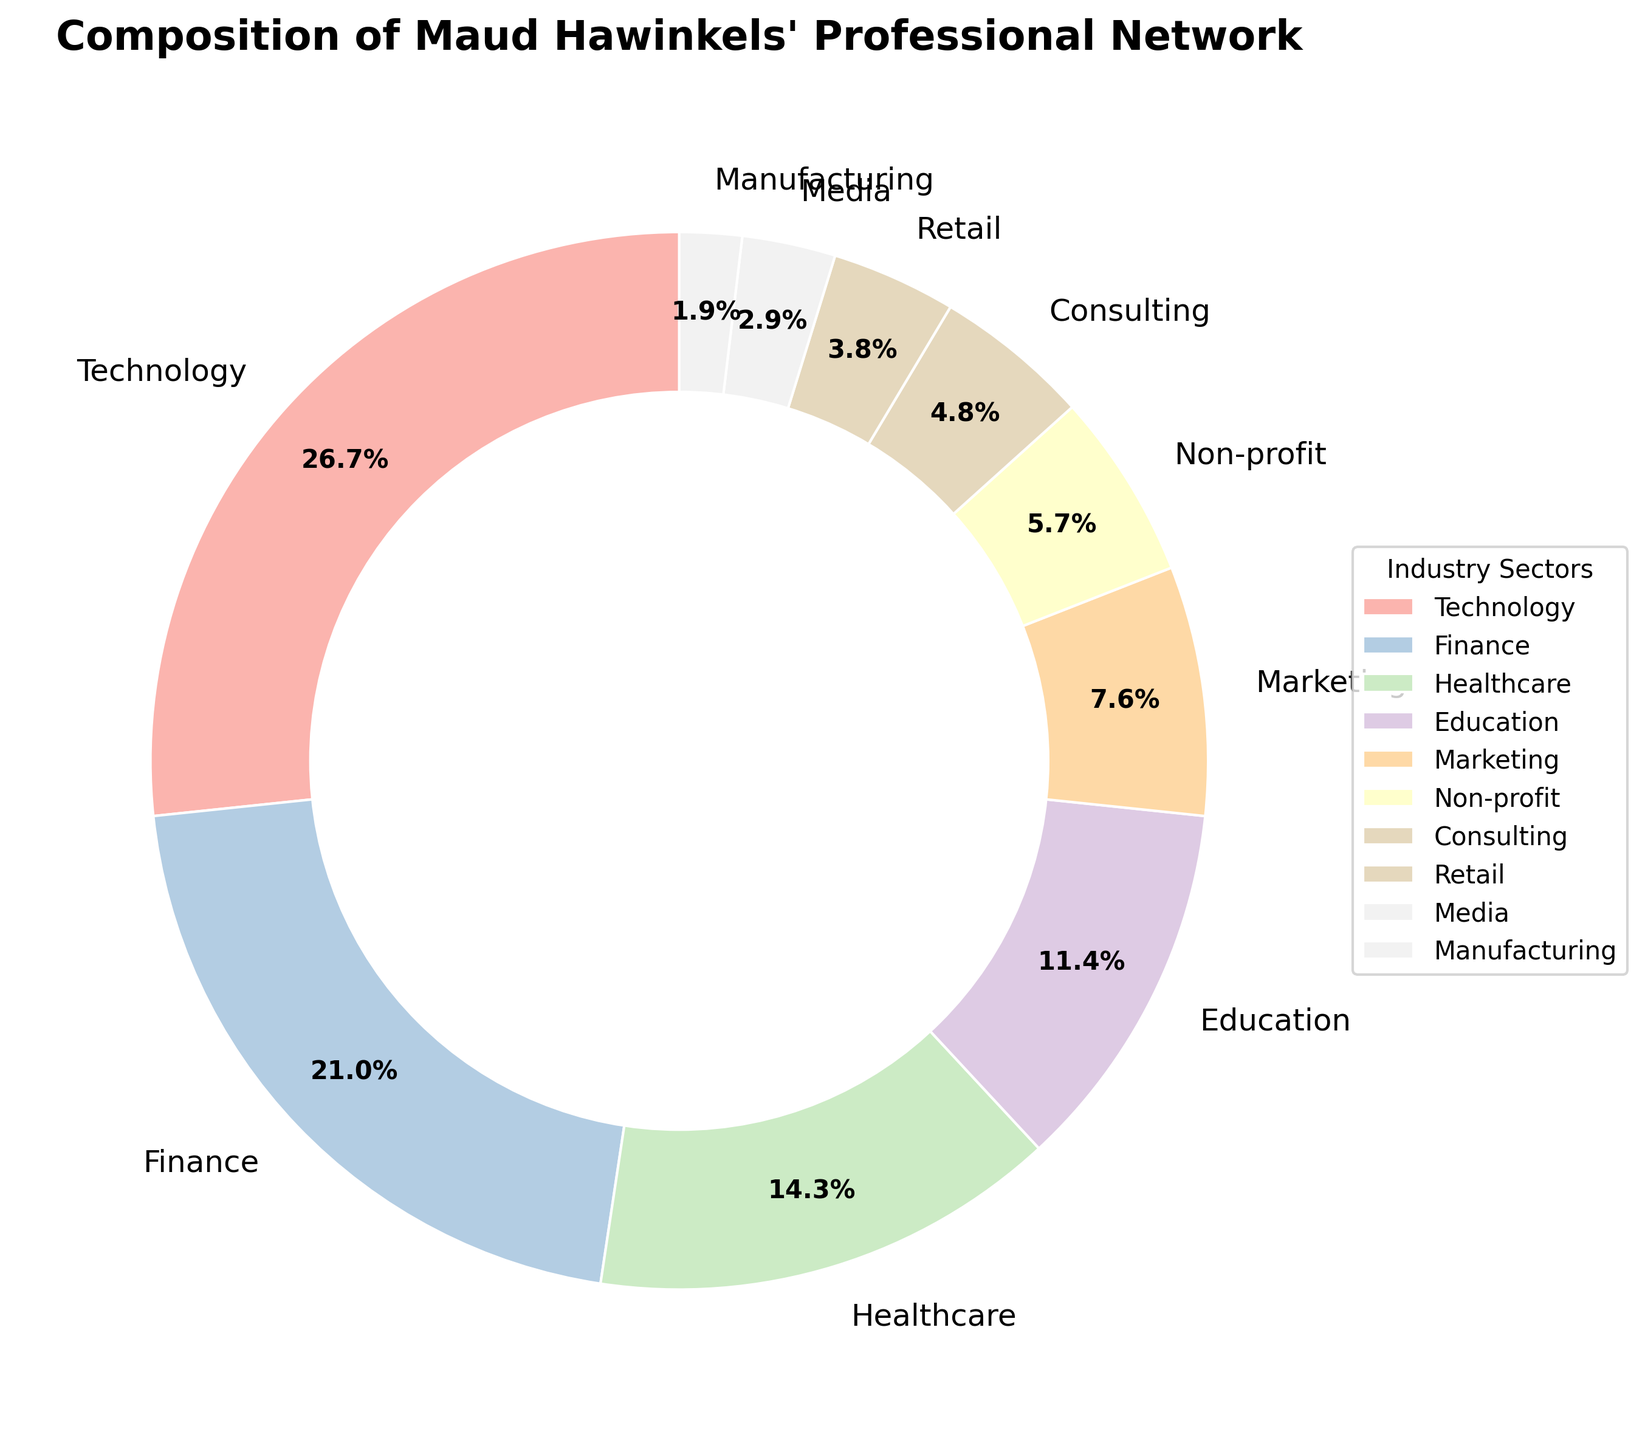What is the total percentage of Maud Hawinkels' professional network in the Technology and Finance sectors? First, locate the percentage for each sector from the pie chart: Technology is 28%, and Finance is 22%. Add these two percentages together: 28% + 22% = 50%.
Answer: 50% Which industry sector has the smallest representation in Maud Hawinkels' professional network? From the pie chart, the Manufacturing sector has the smallest percentage at 2%.
Answer: Manufacturing How many sectors contribute less than 10% each to Maud Hawinkels' professional network? Identify the sectors that have a percentage below 10% by visual inspection of the pie chart: Marketing (8%), Non-profit (6%), Consulting (5%), Retail (4%), Media (3%), and Manufacturing (2%). Count these sectors: 6 sectors total.
Answer: 6 How does the percentage of the Healthcare sector compare to the Education sector in Maud Hawinkels' professional network? From the pie chart, Healthcare is at 15% and Education is at 12%. Subtract the Education percentage from Healthcare: 15% - 12% = 3%. Healthcare is larger by 3%.
Answer: Healthcare is larger by 3% What is the combined percentage of the Consulting, Retail, and Media sectors in Maud Hawinkels' professional network? Locate the percentages for each sector: Consulting is 5%, Retail is 4%, and Media is 3%. Add these percentages together: 5% + 4% + 3% = 12%.
Answer: 12% What color is used to represent the Finance sector? Identify the segment labeled "Finance" on the pie chart and observe its color. The Finance sector is represented by the second segment in a pastel color (visually similar to a light blue/green).
Answer: Light blue/green Which sector is represented by the largest segment of the pie chart, and what is its corresponding percentage? The largest segment of the pie chart is labeled "Technology," which represents 28% of the network.
Answer: Technology, 28% If we add the percentages of the Technology, Healthcare, and Marketing sectors, what is their total representation in the network? Locate the percentages for each sector: Technology (28%), Healthcare (15%), and Marketing (8%). Add these percentages together: 28% + 15% + 8% = 51%.
Answer: 51% Out of the sectors listed, which one is placed directly opposite the Education sector in the pie chart? Visually inspect the pie chart to identify the sector placed on the opposite side of the circle from Education (assumed to be placed at 180 degrees). The Media sector, placed near the bottom, is opposite Education.
Answer: Media 